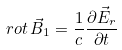Convert formula to latex. <formula><loc_0><loc_0><loc_500><loc_500>r o t \, \vec { B } _ { 1 } = \frac { 1 } { c } \frac { \partial \vec { E } _ { r } } { \partial t }</formula> 